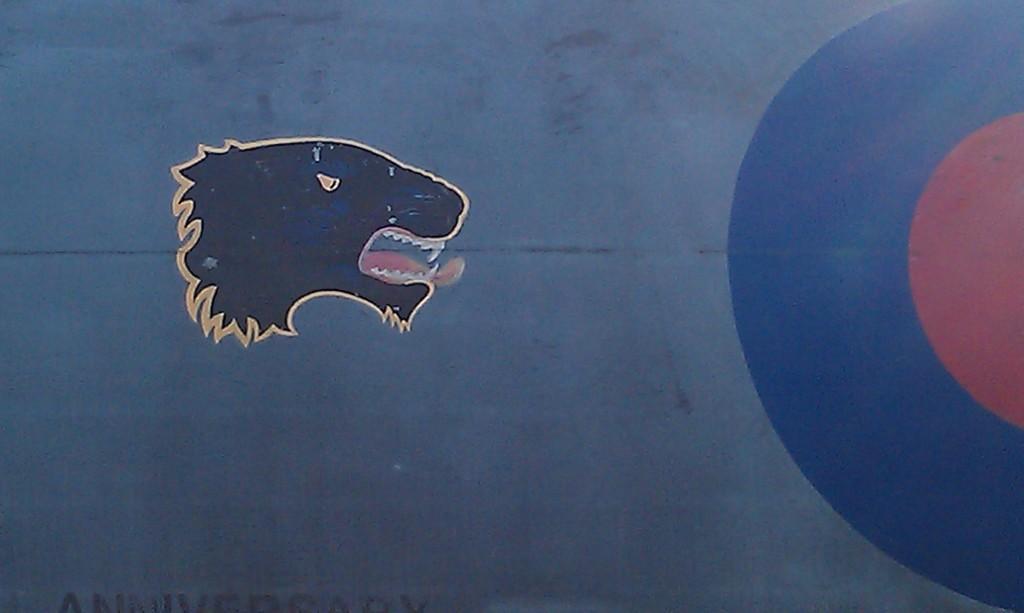Can you describe this image briefly? In this image we can see the painting of an animal's face. 